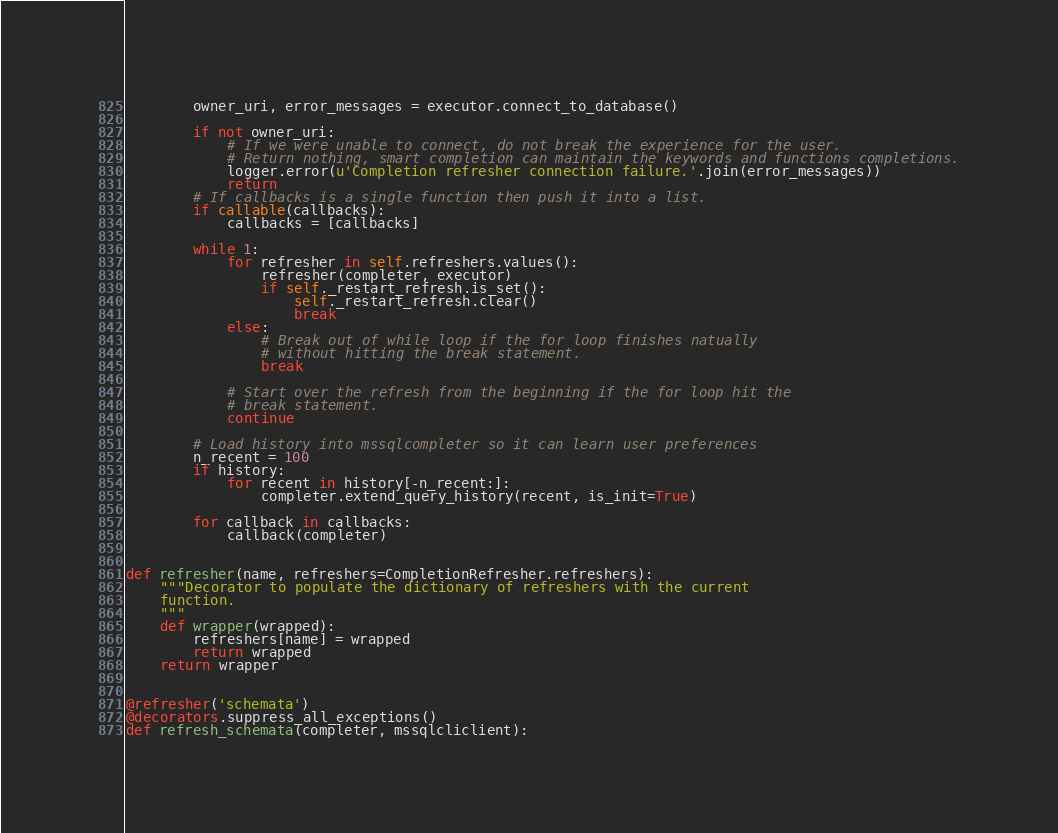<code> <loc_0><loc_0><loc_500><loc_500><_Python_>        owner_uri, error_messages = executor.connect_to_database()

        if not owner_uri:
            # If we were unable to connect, do not break the experience for the user.
            # Return nothing, smart completion can maintain the keywords and functions completions.
            logger.error(u'Completion refresher connection failure.'.join(error_messages))
            return
        # If callbacks is a single function then push it into a list.
        if callable(callbacks):
            callbacks = [callbacks]

        while 1:
            for refresher in self.refreshers.values():
                refresher(completer, executor)
                if self._restart_refresh.is_set():
                    self._restart_refresh.clear()
                    break
            else:
                # Break out of while loop if the for loop finishes natually
                # without hitting the break statement.
                break

            # Start over the refresh from the beginning if the for loop hit the
            # break statement.
            continue

        # Load history into mssqlcompleter so it can learn user preferences
        n_recent = 100
        if history:
            for recent in history[-n_recent:]:
                completer.extend_query_history(recent, is_init=True)

        for callback in callbacks:
            callback(completer)


def refresher(name, refreshers=CompletionRefresher.refreshers):
    """Decorator to populate the dictionary of refreshers with the current
    function.
    """
    def wrapper(wrapped):
        refreshers[name] = wrapped
        return wrapped
    return wrapper


@refresher('schemata')
@decorators.suppress_all_exceptions()
def refresh_schemata(completer, mssqlcliclient):</code> 